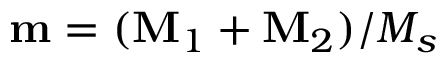<formula> <loc_0><loc_0><loc_500><loc_500>m = ( M _ { 1 } + M _ { 2 } ) / M _ { s }</formula> 